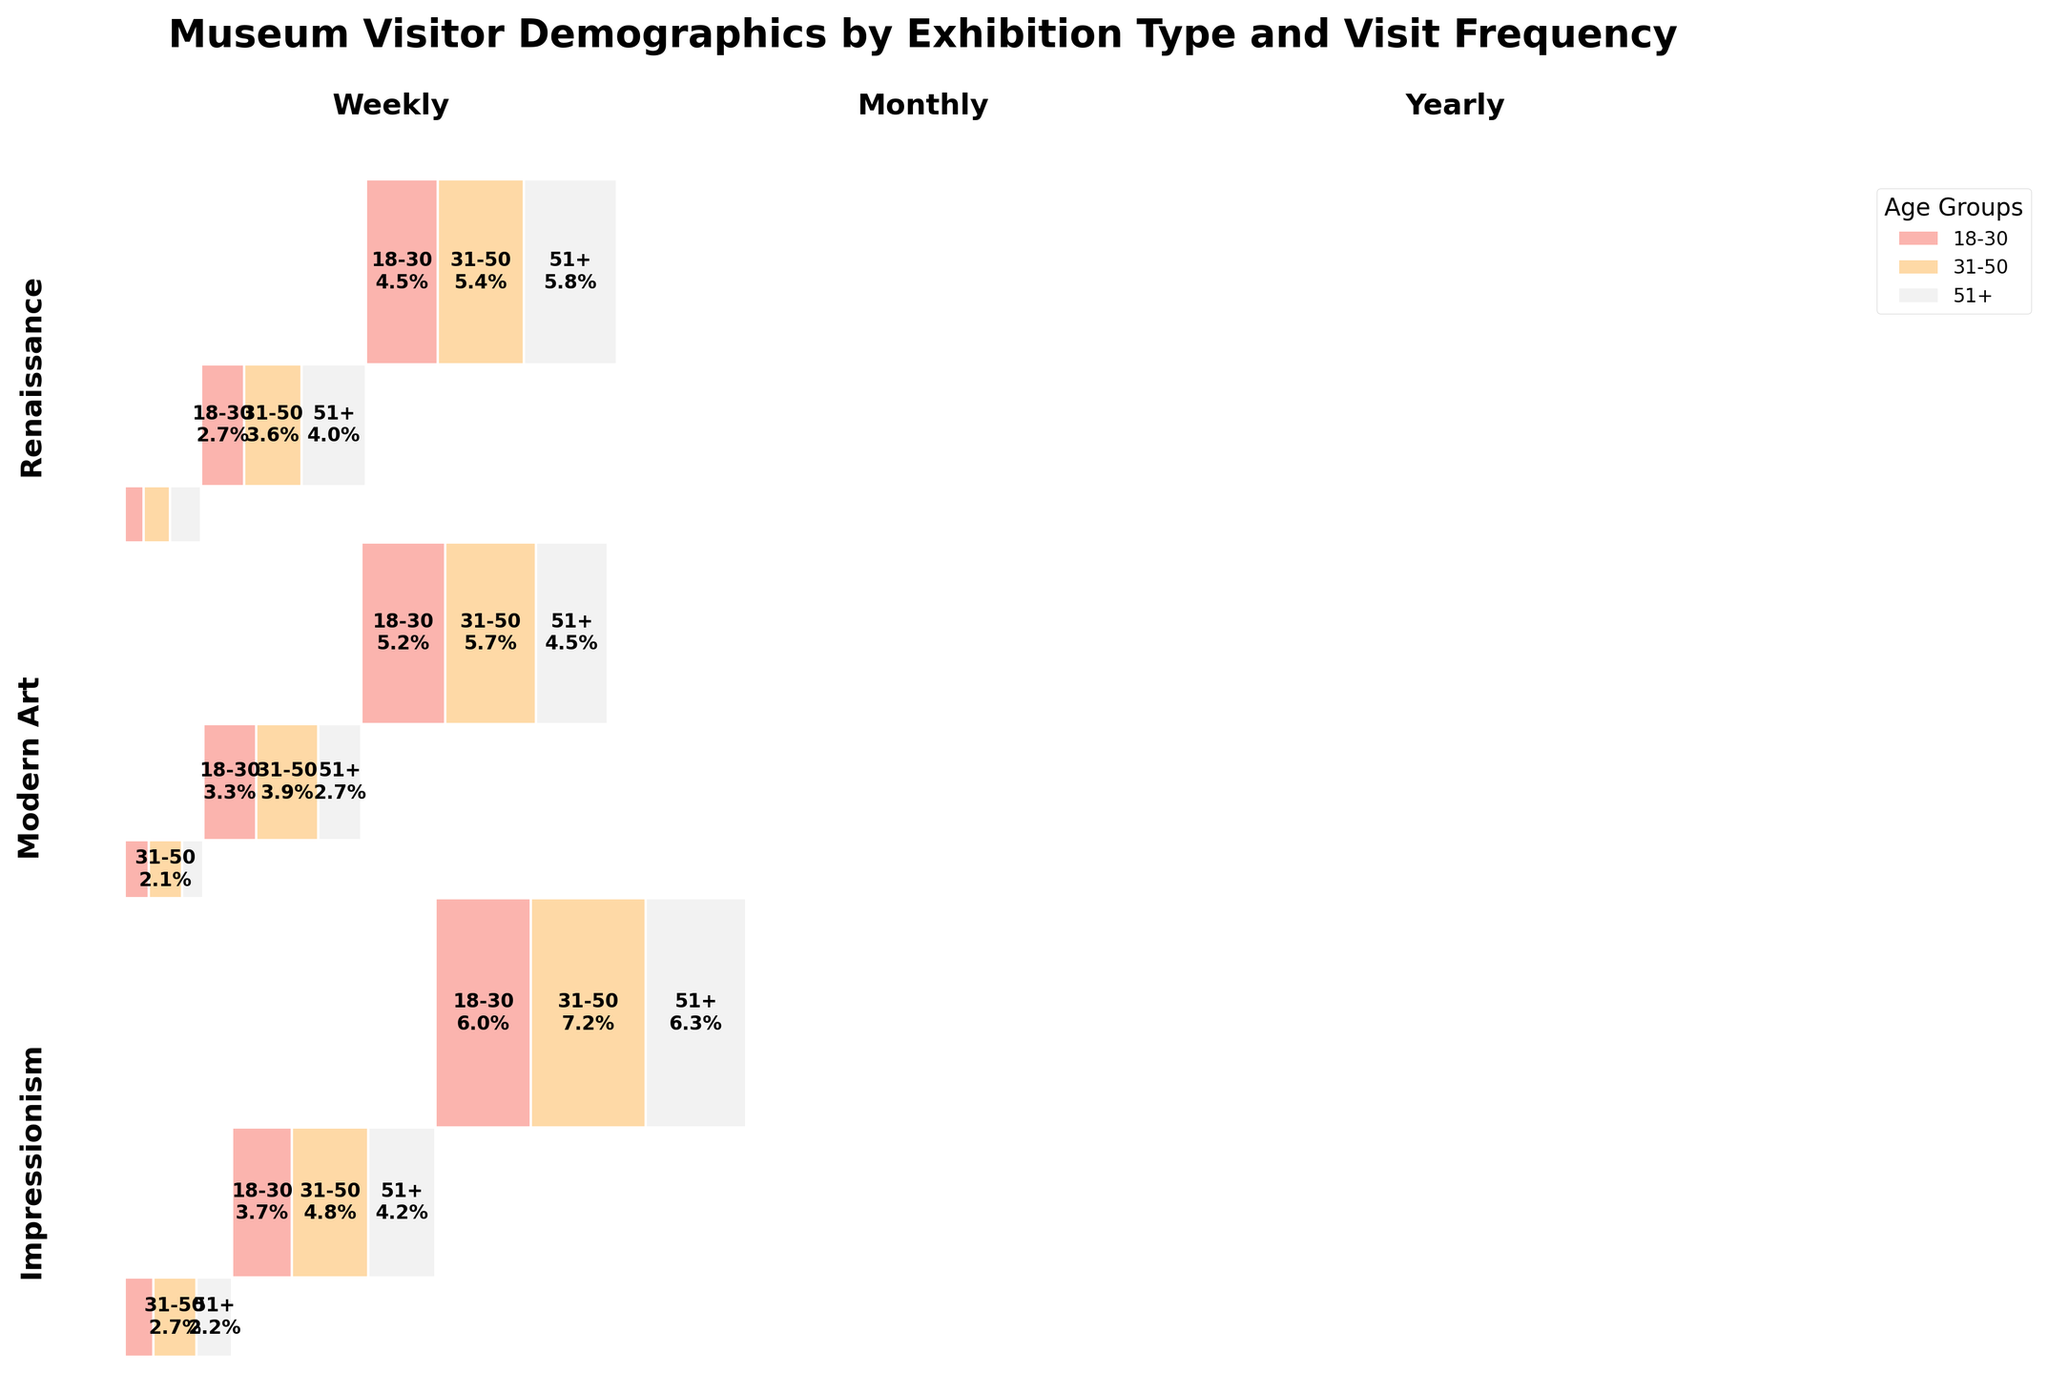What is the title of the plot? The title is typically found at the top of the figure, summarizing the key information it represents.
Answer: Museum Visitor Demographics by Exhibition Type and Visit Frequency Which age group visits the Renaissance exhibitions the least frequently? By looking at the smallest rectangles within each exhibition type segment for the Renaissance, one can see which age group has the least area.
Answer: 18-30 Which exhibition type has the most yearly visitors from the 31-50 age group? To answer this, find the rectangles corresponding to the 31-50 age group in each exhibition and compare their areas under the 'Yearly' visit category.
Answer: Impressionism Are there more monthly visitors aged 51+ for Impressionism or Modern Art? Compare the area of the rectangles for the 51+ age group under the 'Monthly' category for the Impressionism and Modern Art sections.
Answer: Impressionism How many distinct colors are used to represent the age groups in the plot? Examine the legend or the colored rectangles within the plot to count the number of distinct colors used.
Answer: Three Which age group has the largest proportion of visitors for weekly visits in Modern Art exhibitions? Look at the Modern Art section under Weekly visits and identify the largest rectangle among the age groups.
Answer: 31-50 Compare the proportions of visitors aged 18-30 who visit the museum yearly for Impressionism and Renaissance exhibitions. Which is larger? Locate the 18-30 age group in the Yearly category within both Impressionism and Renaissance sections, then compare their areas to see which is larger.
Answer: Renaissance What is the relative proportion of weekly visitors to monthly visitors for the 51+ age group in Impressionism exhibitions? Calculate the ratio of the sizes of the rectangles representing the 51+ age group under Weekly and Monthly visits in the Impressionism section.
Answer: Smaller for Weekly What age group contributes the most to the overall number of visitors across all exhibition types? Summarize the largest combined areas of the rectangles for each age group across all exhibition types and visit frequencies.
Answer: 31-50 